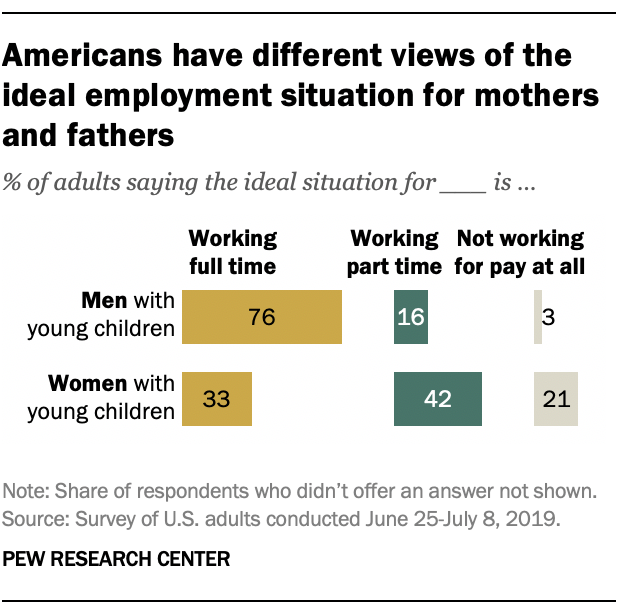Specify some key components in this picture. The sum of the percentage for not working for pay at all is 24%. According to a recent survey, 76% of men with young children work full-time. 